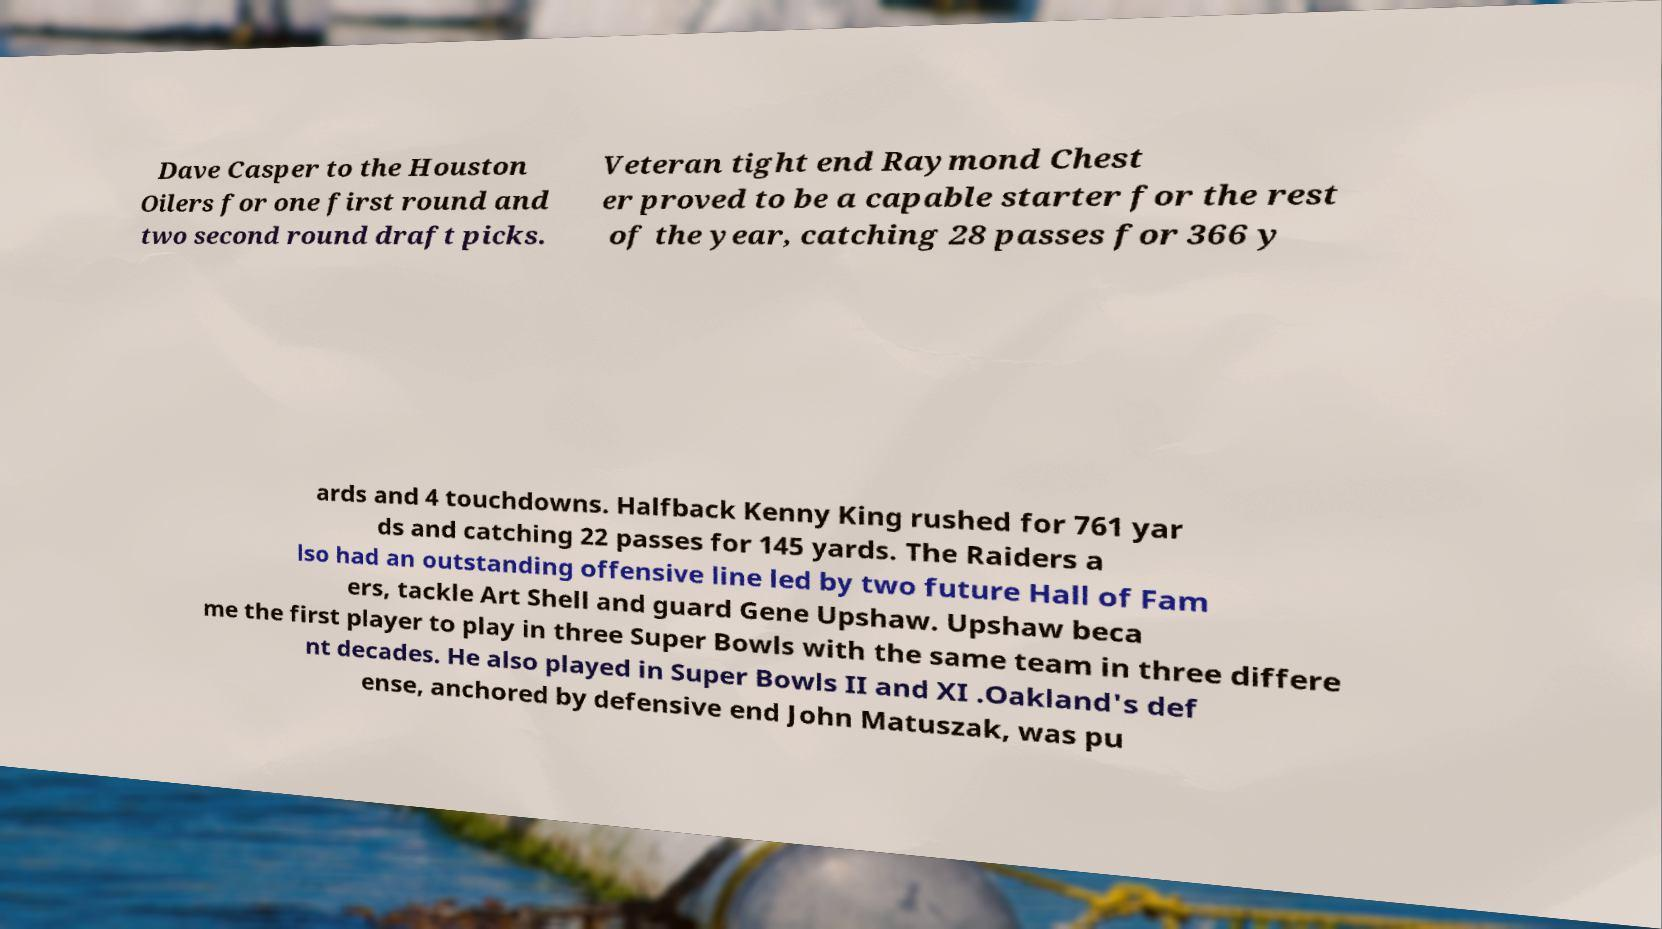What messages or text are displayed in this image? I need them in a readable, typed format. Dave Casper to the Houston Oilers for one first round and two second round draft picks. Veteran tight end Raymond Chest er proved to be a capable starter for the rest of the year, catching 28 passes for 366 y ards and 4 touchdowns. Halfback Kenny King rushed for 761 yar ds and catching 22 passes for 145 yards. The Raiders a lso had an outstanding offensive line led by two future Hall of Fam ers, tackle Art Shell and guard Gene Upshaw. Upshaw beca me the first player to play in three Super Bowls with the same team in three differe nt decades. He also played in Super Bowls II and XI .Oakland's def ense, anchored by defensive end John Matuszak, was pu 